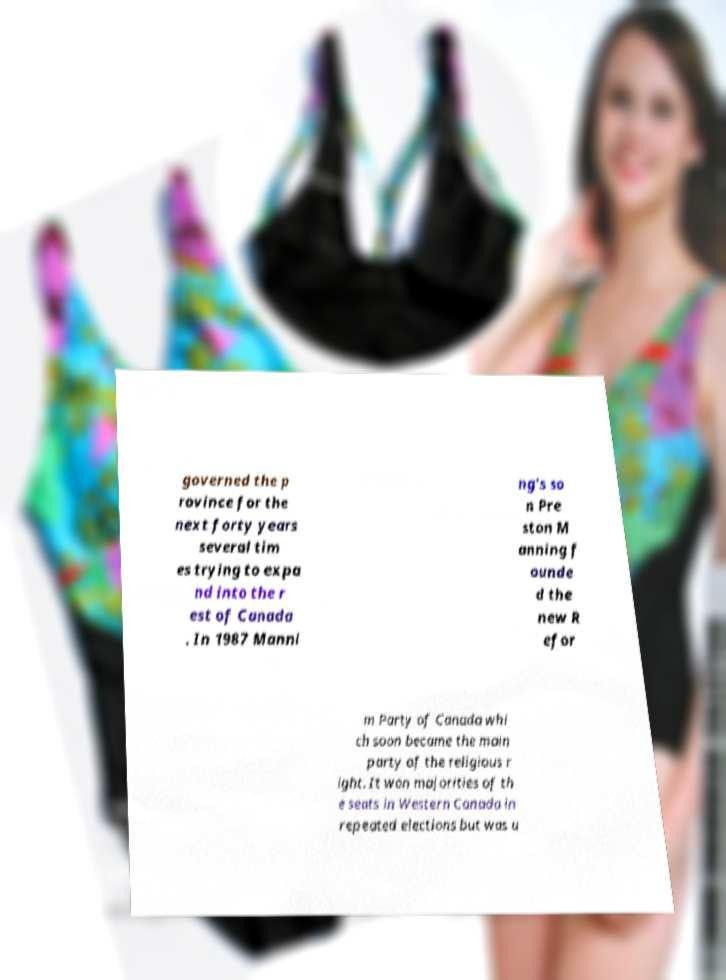There's text embedded in this image that I need extracted. Can you transcribe it verbatim? governed the p rovince for the next forty years several tim es trying to expa nd into the r est of Canada . In 1987 Manni ng's so n Pre ston M anning f ounde d the new R efor m Party of Canada whi ch soon became the main party of the religious r ight. It won majorities of th e seats in Western Canada in repeated elections but was u 